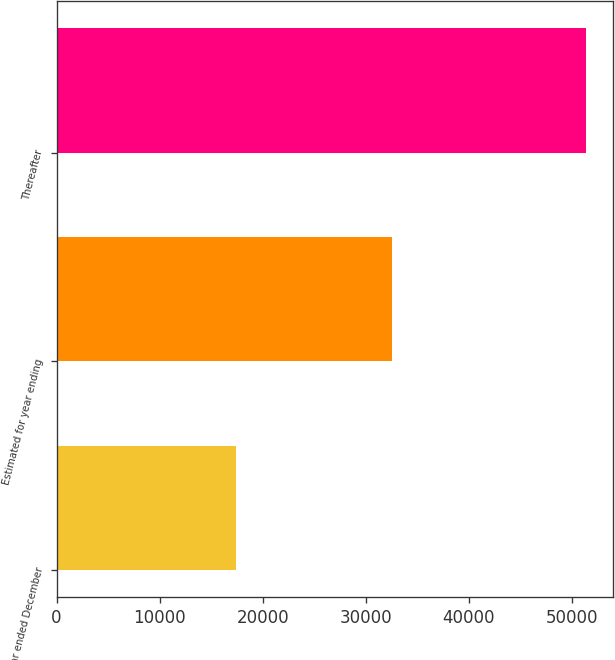<chart> <loc_0><loc_0><loc_500><loc_500><bar_chart><fcel>Actual for year ended December<fcel>Estimated for year ending<fcel>Thereafter<nl><fcel>17449.7<fcel>32532.5<fcel>51386<nl></chart> 